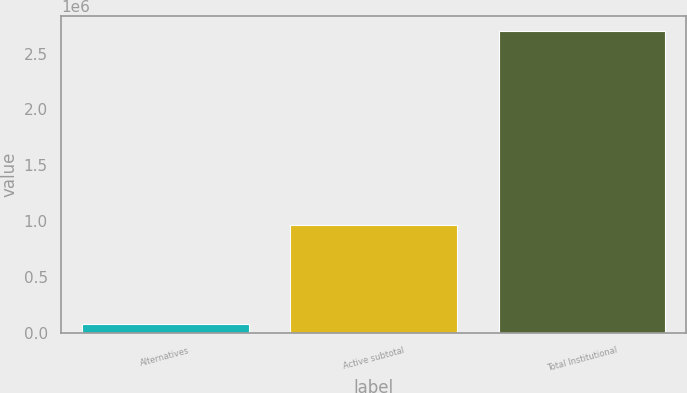Convert chart to OTSL. <chart><loc_0><loc_0><loc_500><loc_500><bar_chart><fcel>Alternatives<fcel>Active subtotal<fcel>Total Institutional<nl><fcel>74941<fcel>962852<fcel>2.70163e+06<nl></chart> 